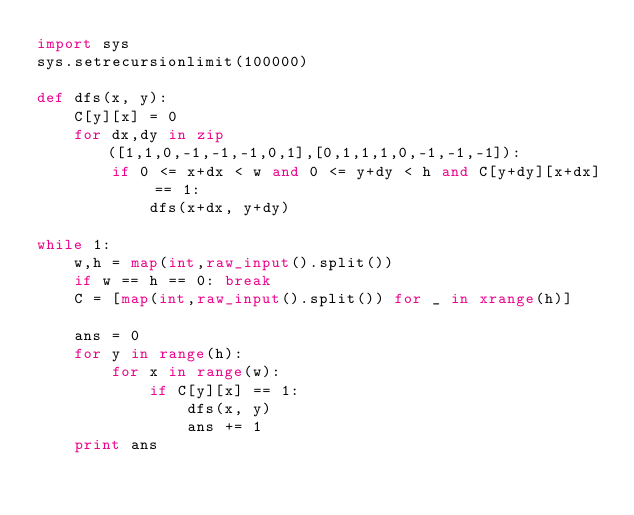<code> <loc_0><loc_0><loc_500><loc_500><_Python_>import sys
sys.setrecursionlimit(100000)

def dfs(x, y):
    C[y][x] = 0
    for dx,dy in zip([1,1,0,-1,-1,-1,0,1],[0,1,1,1,0,-1,-1,-1]):
        if 0 <= x+dx < w and 0 <= y+dy < h and C[y+dy][x+dx] == 1:
            dfs(x+dx, y+dy)

while 1:
    w,h = map(int,raw_input().split())
    if w == h == 0: break
    C = [map(int,raw_input().split()) for _ in xrange(h)]

    ans = 0
    for y in range(h):
        for x in range(w):
            if C[y][x] == 1:
                dfs(x, y)
                ans += 1
    print ans</code> 